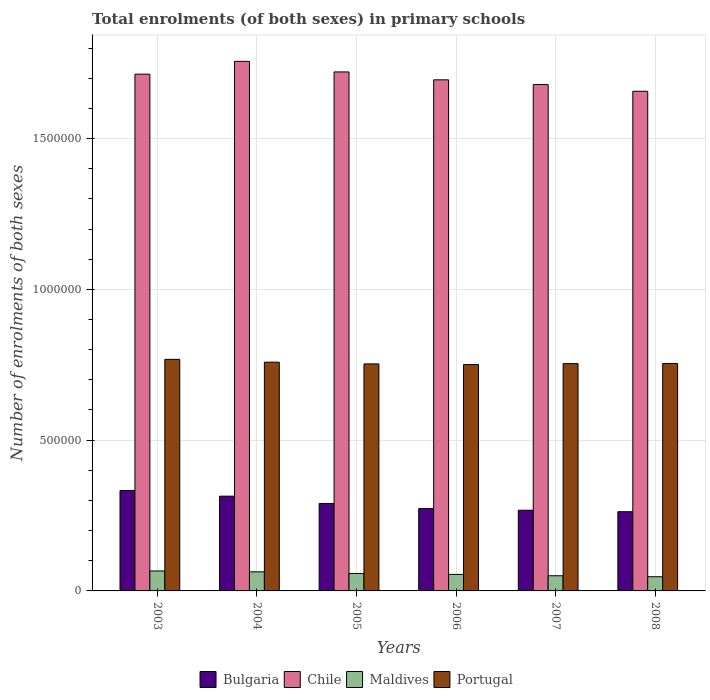Are the number of bars per tick equal to the number of legend labels?
Keep it short and to the point. Yes. Are the number of bars on each tick of the X-axis equal?
Offer a very short reply. Yes. What is the label of the 2nd group of bars from the left?
Your answer should be compact. 2004. In how many cases, is the number of bars for a given year not equal to the number of legend labels?
Give a very brief answer. 0. What is the number of enrolments in primary schools in Bulgaria in 2006?
Give a very brief answer. 2.73e+05. Across all years, what is the maximum number of enrolments in primary schools in Portugal?
Offer a terse response. 7.68e+05. Across all years, what is the minimum number of enrolments in primary schools in Chile?
Give a very brief answer. 1.66e+06. What is the total number of enrolments in primary schools in Maldives in the graph?
Offer a terse response. 3.39e+05. What is the difference between the number of enrolments in primary schools in Bulgaria in 2006 and that in 2007?
Provide a short and direct response. 5461. What is the difference between the number of enrolments in primary schools in Maldives in 2008 and the number of enrolments in primary schools in Portugal in 2004?
Provide a short and direct response. -7.11e+05. What is the average number of enrolments in primary schools in Chile per year?
Give a very brief answer. 1.70e+06. In the year 2005, what is the difference between the number of enrolments in primary schools in Chile and number of enrolments in primary schools in Maldives?
Provide a succinct answer. 1.66e+06. In how many years, is the number of enrolments in primary schools in Chile greater than 400000?
Offer a terse response. 6. What is the ratio of the number of enrolments in primary schools in Bulgaria in 2005 to that in 2008?
Your response must be concise. 1.1. Is the difference between the number of enrolments in primary schools in Chile in 2004 and 2007 greater than the difference between the number of enrolments in primary schools in Maldives in 2004 and 2007?
Your response must be concise. Yes. What is the difference between the highest and the second highest number of enrolments in primary schools in Bulgaria?
Make the answer very short. 1.88e+04. What is the difference between the highest and the lowest number of enrolments in primary schools in Maldives?
Offer a terse response. 1.91e+04. In how many years, is the number of enrolments in primary schools in Portugal greater than the average number of enrolments in primary schools in Portugal taken over all years?
Give a very brief answer. 2. Is the sum of the number of enrolments in primary schools in Chile in 2007 and 2008 greater than the maximum number of enrolments in primary schools in Maldives across all years?
Ensure brevity in your answer.  Yes. Is it the case that in every year, the sum of the number of enrolments in primary schools in Maldives and number of enrolments in primary schools in Portugal is greater than the sum of number of enrolments in primary schools in Chile and number of enrolments in primary schools in Bulgaria?
Keep it short and to the point. Yes. What is the difference between two consecutive major ticks on the Y-axis?
Give a very brief answer. 5.00e+05. Are the values on the major ticks of Y-axis written in scientific E-notation?
Your response must be concise. No. Does the graph contain grids?
Offer a terse response. Yes. Where does the legend appear in the graph?
Ensure brevity in your answer.  Bottom center. What is the title of the graph?
Provide a short and direct response. Total enrolments (of both sexes) in primary schools. What is the label or title of the X-axis?
Make the answer very short. Years. What is the label or title of the Y-axis?
Offer a terse response. Number of enrolments of both sexes. What is the Number of enrolments of both sexes of Bulgaria in 2003?
Your response must be concise. 3.33e+05. What is the Number of enrolments of both sexes in Chile in 2003?
Offer a terse response. 1.71e+06. What is the Number of enrolments of both sexes of Maldives in 2003?
Make the answer very short. 6.62e+04. What is the Number of enrolments of both sexes of Portugal in 2003?
Offer a very short reply. 7.68e+05. What is the Number of enrolments of both sexes in Bulgaria in 2004?
Ensure brevity in your answer.  3.14e+05. What is the Number of enrolments of both sexes of Chile in 2004?
Provide a short and direct response. 1.76e+06. What is the Number of enrolments of both sexes of Maldives in 2004?
Keep it short and to the point. 6.33e+04. What is the Number of enrolments of both sexes of Portugal in 2004?
Provide a short and direct response. 7.58e+05. What is the Number of enrolments of both sexes in Bulgaria in 2005?
Keep it short and to the point. 2.90e+05. What is the Number of enrolments of both sexes in Chile in 2005?
Provide a succinct answer. 1.72e+06. What is the Number of enrolments of both sexes of Maldives in 2005?
Keep it short and to the point. 5.79e+04. What is the Number of enrolments of both sexes of Portugal in 2005?
Your response must be concise. 7.53e+05. What is the Number of enrolments of both sexes of Bulgaria in 2006?
Offer a terse response. 2.73e+05. What is the Number of enrolments of both sexes in Chile in 2006?
Your answer should be compact. 1.69e+06. What is the Number of enrolments of both sexes in Maldives in 2006?
Your answer should be compact. 5.48e+04. What is the Number of enrolments of both sexes of Portugal in 2006?
Keep it short and to the point. 7.50e+05. What is the Number of enrolments of both sexes in Bulgaria in 2007?
Ensure brevity in your answer.  2.68e+05. What is the Number of enrolments of both sexes of Chile in 2007?
Provide a succinct answer. 1.68e+06. What is the Number of enrolments of both sexes of Maldives in 2007?
Your answer should be compact. 5.03e+04. What is the Number of enrolments of both sexes of Portugal in 2007?
Ensure brevity in your answer.  7.54e+05. What is the Number of enrolments of both sexes of Bulgaria in 2008?
Give a very brief answer. 2.63e+05. What is the Number of enrolments of both sexes in Chile in 2008?
Ensure brevity in your answer.  1.66e+06. What is the Number of enrolments of both sexes in Maldives in 2008?
Provide a short and direct response. 4.71e+04. What is the Number of enrolments of both sexes of Portugal in 2008?
Ensure brevity in your answer.  7.54e+05. Across all years, what is the maximum Number of enrolments of both sexes in Bulgaria?
Your answer should be very brief. 3.33e+05. Across all years, what is the maximum Number of enrolments of both sexes of Chile?
Offer a terse response. 1.76e+06. Across all years, what is the maximum Number of enrolments of both sexes of Maldives?
Offer a very short reply. 6.62e+04. Across all years, what is the maximum Number of enrolments of both sexes in Portugal?
Offer a terse response. 7.68e+05. Across all years, what is the minimum Number of enrolments of both sexes in Bulgaria?
Offer a very short reply. 2.63e+05. Across all years, what is the minimum Number of enrolments of both sexes in Chile?
Give a very brief answer. 1.66e+06. Across all years, what is the minimum Number of enrolments of both sexes in Maldives?
Provide a succinct answer. 4.71e+04. Across all years, what is the minimum Number of enrolments of both sexes in Portugal?
Your response must be concise. 7.50e+05. What is the total Number of enrolments of both sexes of Bulgaria in the graph?
Offer a terse response. 1.74e+06. What is the total Number of enrolments of both sexes of Chile in the graph?
Give a very brief answer. 1.02e+07. What is the total Number of enrolments of both sexes in Maldives in the graph?
Your answer should be very brief. 3.39e+05. What is the total Number of enrolments of both sexes in Portugal in the graph?
Keep it short and to the point. 4.54e+06. What is the difference between the Number of enrolments of both sexes of Bulgaria in 2003 and that in 2004?
Provide a succinct answer. 1.88e+04. What is the difference between the Number of enrolments of both sexes of Chile in 2003 and that in 2004?
Offer a very short reply. -4.25e+04. What is the difference between the Number of enrolments of both sexes of Maldives in 2003 and that in 2004?
Provide a short and direct response. 2869. What is the difference between the Number of enrolments of both sexes in Portugal in 2003 and that in 2004?
Your answer should be very brief. 9396. What is the difference between the Number of enrolments of both sexes in Bulgaria in 2003 and that in 2005?
Provide a short and direct response. 4.30e+04. What is the difference between the Number of enrolments of both sexes in Chile in 2003 and that in 2005?
Ensure brevity in your answer.  -7413. What is the difference between the Number of enrolments of both sexes of Maldives in 2003 and that in 2005?
Provide a succinct answer. 8296. What is the difference between the Number of enrolments of both sexes of Portugal in 2003 and that in 2005?
Provide a succinct answer. 1.51e+04. What is the difference between the Number of enrolments of both sexes in Bulgaria in 2003 and that in 2006?
Provide a succinct answer. 6.00e+04. What is the difference between the Number of enrolments of both sexes of Chile in 2003 and that in 2006?
Offer a very short reply. 1.88e+04. What is the difference between the Number of enrolments of both sexes of Maldives in 2003 and that in 2006?
Offer a terse response. 1.14e+04. What is the difference between the Number of enrolments of both sexes of Portugal in 2003 and that in 2006?
Offer a very short reply. 1.74e+04. What is the difference between the Number of enrolments of both sexes of Bulgaria in 2003 and that in 2007?
Offer a very short reply. 6.54e+04. What is the difference between the Number of enrolments of both sexes of Chile in 2003 and that in 2007?
Make the answer very short. 3.45e+04. What is the difference between the Number of enrolments of both sexes in Maldives in 2003 and that in 2007?
Provide a short and direct response. 1.59e+04. What is the difference between the Number of enrolments of both sexes in Portugal in 2003 and that in 2007?
Ensure brevity in your answer.  1.42e+04. What is the difference between the Number of enrolments of both sexes of Bulgaria in 2003 and that in 2008?
Ensure brevity in your answer.  7.03e+04. What is the difference between the Number of enrolments of both sexes in Chile in 2003 and that in 2008?
Give a very brief answer. 5.67e+04. What is the difference between the Number of enrolments of both sexes in Maldives in 2003 and that in 2008?
Your answer should be very brief. 1.91e+04. What is the difference between the Number of enrolments of both sexes of Portugal in 2003 and that in 2008?
Provide a short and direct response. 1.37e+04. What is the difference between the Number of enrolments of both sexes of Bulgaria in 2004 and that in 2005?
Make the answer very short. 2.42e+04. What is the difference between the Number of enrolments of both sexes in Chile in 2004 and that in 2005?
Offer a very short reply. 3.50e+04. What is the difference between the Number of enrolments of both sexes of Maldives in 2004 and that in 2005?
Ensure brevity in your answer.  5427. What is the difference between the Number of enrolments of both sexes of Portugal in 2004 and that in 2005?
Give a very brief answer. 5737. What is the difference between the Number of enrolments of both sexes in Bulgaria in 2004 and that in 2006?
Your answer should be very brief. 4.12e+04. What is the difference between the Number of enrolments of both sexes in Chile in 2004 and that in 2006?
Provide a succinct answer. 6.12e+04. What is the difference between the Number of enrolments of both sexes of Maldives in 2004 and that in 2006?
Make the answer very short. 8530. What is the difference between the Number of enrolments of both sexes of Portugal in 2004 and that in 2006?
Provide a short and direct response. 7983. What is the difference between the Number of enrolments of both sexes of Bulgaria in 2004 and that in 2007?
Offer a terse response. 4.66e+04. What is the difference between the Number of enrolments of both sexes of Chile in 2004 and that in 2007?
Your answer should be compact. 7.70e+04. What is the difference between the Number of enrolments of both sexes of Maldives in 2004 and that in 2007?
Offer a terse response. 1.30e+04. What is the difference between the Number of enrolments of both sexes of Portugal in 2004 and that in 2007?
Give a very brief answer. 4830. What is the difference between the Number of enrolments of both sexes in Bulgaria in 2004 and that in 2008?
Make the answer very short. 5.15e+04. What is the difference between the Number of enrolments of both sexes of Chile in 2004 and that in 2008?
Provide a succinct answer. 9.92e+04. What is the difference between the Number of enrolments of both sexes in Maldives in 2004 and that in 2008?
Your answer should be compact. 1.62e+04. What is the difference between the Number of enrolments of both sexes of Portugal in 2004 and that in 2008?
Your answer should be very brief. 4334. What is the difference between the Number of enrolments of both sexes of Bulgaria in 2005 and that in 2006?
Provide a short and direct response. 1.70e+04. What is the difference between the Number of enrolments of both sexes of Chile in 2005 and that in 2006?
Give a very brief answer. 2.62e+04. What is the difference between the Number of enrolments of both sexes of Maldives in 2005 and that in 2006?
Your response must be concise. 3103. What is the difference between the Number of enrolments of both sexes of Portugal in 2005 and that in 2006?
Provide a short and direct response. 2246. What is the difference between the Number of enrolments of both sexes in Bulgaria in 2005 and that in 2007?
Your answer should be very brief. 2.24e+04. What is the difference between the Number of enrolments of both sexes of Chile in 2005 and that in 2007?
Ensure brevity in your answer.  4.19e+04. What is the difference between the Number of enrolments of both sexes in Maldives in 2005 and that in 2007?
Ensure brevity in your answer.  7603. What is the difference between the Number of enrolments of both sexes in Portugal in 2005 and that in 2007?
Give a very brief answer. -907. What is the difference between the Number of enrolments of both sexes in Bulgaria in 2005 and that in 2008?
Offer a very short reply. 2.73e+04. What is the difference between the Number of enrolments of both sexes of Chile in 2005 and that in 2008?
Offer a very short reply. 6.41e+04. What is the difference between the Number of enrolments of both sexes in Maldives in 2005 and that in 2008?
Your response must be concise. 1.08e+04. What is the difference between the Number of enrolments of both sexes in Portugal in 2005 and that in 2008?
Your response must be concise. -1403. What is the difference between the Number of enrolments of both sexes of Bulgaria in 2006 and that in 2007?
Give a very brief answer. 5461. What is the difference between the Number of enrolments of both sexes in Chile in 2006 and that in 2007?
Your response must be concise. 1.57e+04. What is the difference between the Number of enrolments of both sexes of Maldives in 2006 and that in 2007?
Give a very brief answer. 4500. What is the difference between the Number of enrolments of both sexes of Portugal in 2006 and that in 2007?
Give a very brief answer. -3153. What is the difference between the Number of enrolments of both sexes in Bulgaria in 2006 and that in 2008?
Provide a short and direct response. 1.03e+04. What is the difference between the Number of enrolments of both sexes of Chile in 2006 and that in 2008?
Make the answer very short. 3.80e+04. What is the difference between the Number of enrolments of both sexes of Maldives in 2006 and that in 2008?
Keep it short and to the point. 7688. What is the difference between the Number of enrolments of both sexes of Portugal in 2006 and that in 2008?
Your response must be concise. -3649. What is the difference between the Number of enrolments of both sexes of Bulgaria in 2007 and that in 2008?
Your answer should be very brief. 4883. What is the difference between the Number of enrolments of both sexes in Chile in 2007 and that in 2008?
Offer a very short reply. 2.22e+04. What is the difference between the Number of enrolments of both sexes of Maldives in 2007 and that in 2008?
Keep it short and to the point. 3188. What is the difference between the Number of enrolments of both sexes of Portugal in 2007 and that in 2008?
Ensure brevity in your answer.  -496. What is the difference between the Number of enrolments of both sexes in Bulgaria in 2003 and the Number of enrolments of both sexes in Chile in 2004?
Your answer should be very brief. -1.42e+06. What is the difference between the Number of enrolments of both sexes of Bulgaria in 2003 and the Number of enrolments of both sexes of Maldives in 2004?
Provide a short and direct response. 2.70e+05. What is the difference between the Number of enrolments of both sexes in Bulgaria in 2003 and the Number of enrolments of both sexes in Portugal in 2004?
Make the answer very short. -4.25e+05. What is the difference between the Number of enrolments of both sexes in Chile in 2003 and the Number of enrolments of both sexes in Maldives in 2004?
Your answer should be very brief. 1.65e+06. What is the difference between the Number of enrolments of both sexes of Chile in 2003 and the Number of enrolments of both sexes of Portugal in 2004?
Offer a very short reply. 9.55e+05. What is the difference between the Number of enrolments of both sexes in Maldives in 2003 and the Number of enrolments of both sexes in Portugal in 2004?
Give a very brief answer. -6.92e+05. What is the difference between the Number of enrolments of both sexes of Bulgaria in 2003 and the Number of enrolments of both sexes of Chile in 2005?
Your answer should be compact. -1.39e+06. What is the difference between the Number of enrolments of both sexes of Bulgaria in 2003 and the Number of enrolments of both sexes of Maldives in 2005?
Provide a short and direct response. 2.75e+05. What is the difference between the Number of enrolments of both sexes in Bulgaria in 2003 and the Number of enrolments of both sexes in Portugal in 2005?
Give a very brief answer. -4.20e+05. What is the difference between the Number of enrolments of both sexes of Chile in 2003 and the Number of enrolments of both sexes of Maldives in 2005?
Offer a terse response. 1.66e+06. What is the difference between the Number of enrolments of both sexes in Chile in 2003 and the Number of enrolments of both sexes in Portugal in 2005?
Your answer should be very brief. 9.61e+05. What is the difference between the Number of enrolments of both sexes of Maldives in 2003 and the Number of enrolments of both sexes of Portugal in 2005?
Offer a very short reply. -6.87e+05. What is the difference between the Number of enrolments of both sexes of Bulgaria in 2003 and the Number of enrolments of both sexes of Chile in 2006?
Offer a terse response. -1.36e+06. What is the difference between the Number of enrolments of both sexes of Bulgaria in 2003 and the Number of enrolments of both sexes of Maldives in 2006?
Keep it short and to the point. 2.78e+05. What is the difference between the Number of enrolments of both sexes in Bulgaria in 2003 and the Number of enrolments of both sexes in Portugal in 2006?
Offer a terse response. -4.17e+05. What is the difference between the Number of enrolments of both sexes in Chile in 2003 and the Number of enrolments of both sexes in Maldives in 2006?
Ensure brevity in your answer.  1.66e+06. What is the difference between the Number of enrolments of both sexes in Chile in 2003 and the Number of enrolments of both sexes in Portugal in 2006?
Your answer should be compact. 9.63e+05. What is the difference between the Number of enrolments of both sexes of Maldives in 2003 and the Number of enrolments of both sexes of Portugal in 2006?
Provide a short and direct response. -6.84e+05. What is the difference between the Number of enrolments of both sexes of Bulgaria in 2003 and the Number of enrolments of both sexes of Chile in 2007?
Offer a very short reply. -1.35e+06. What is the difference between the Number of enrolments of both sexes in Bulgaria in 2003 and the Number of enrolments of both sexes in Maldives in 2007?
Your answer should be compact. 2.83e+05. What is the difference between the Number of enrolments of both sexes in Bulgaria in 2003 and the Number of enrolments of both sexes in Portugal in 2007?
Your answer should be compact. -4.21e+05. What is the difference between the Number of enrolments of both sexes in Chile in 2003 and the Number of enrolments of both sexes in Maldives in 2007?
Ensure brevity in your answer.  1.66e+06. What is the difference between the Number of enrolments of both sexes in Chile in 2003 and the Number of enrolments of both sexes in Portugal in 2007?
Your response must be concise. 9.60e+05. What is the difference between the Number of enrolments of both sexes in Maldives in 2003 and the Number of enrolments of both sexes in Portugal in 2007?
Your response must be concise. -6.87e+05. What is the difference between the Number of enrolments of both sexes in Bulgaria in 2003 and the Number of enrolments of both sexes in Chile in 2008?
Give a very brief answer. -1.32e+06. What is the difference between the Number of enrolments of both sexes of Bulgaria in 2003 and the Number of enrolments of both sexes of Maldives in 2008?
Your answer should be very brief. 2.86e+05. What is the difference between the Number of enrolments of both sexes in Bulgaria in 2003 and the Number of enrolments of both sexes in Portugal in 2008?
Your answer should be very brief. -4.21e+05. What is the difference between the Number of enrolments of both sexes in Chile in 2003 and the Number of enrolments of both sexes in Maldives in 2008?
Keep it short and to the point. 1.67e+06. What is the difference between the Number of enrolments of both sexes of Chile in 2003 and the Number of enrolments of both sexes of Portugal in 2008?
Offer a terse response. 9.59e+05. What is the difference between the Number of enrolments of both sexes in Maldives in 2003 and the Number of enrolments of both sexes in Portugal in 2008?
Your answer should be compact. -6.88e+05. What is the difference between the Number of enrolments of both sexes of Bulgaria in 2004 and the Number of enrolments of both sexes of Chile in 2005?
Give a very brief answer. -1.41e+06. What is the difference between the Number of enrolments of both sexes in Bulgaria in 2004 and the Number of enrolments of both sexes in Maldives in 2005?
Your response must be concise. 2.56e+05. What is the difference between the Number of enrolments of both sexes of Bulgaria in 2004 and the Number of enrolments of both sexes of Portugal in 2005?
Give a very brief answer. -4.39e+05. What is the difference between the Number of enrolments of both sexes in Chile in 2004 and the Number of enrolments of both sexes in Maldives in 2005?
Your answer should be compact. 1.70e+06. What is the difference between the Number of enrolments of both sexes of Chile in 2004 and the Number of enrolments of both sexes of Portugal in 2005?
Your answer should be very brief. 1.00e+06. What is the difference between the Number of enrolments of both sexes in Maldives in 2004 and the Number of enrolments of both sexes in Portugal in 2005?
Your response must be concise. -6.89e+05. What is the difference between the Number of enrolments of both sexes of Bulgaria in 2004 and the Number of enrolments of both sexes of Chile in 2006?
Ensure brevity in your answer.  -1.38e+06. What is the difference between the Number of enrolments of both sexes of Bulgaria in 2004 and the Number of enrolments of both sexes of Maldives in 2006?
Offer a very short reply. 2.59e+05. What is the difference between the Number of enrolments of both sexes of Bulgaria in 2004 and the Number of enrolments of both sexes of Portugal in 2006?
Ensure brevity in your answer.  -4.36e+05. What is the difference between the Number of enrolments of both sexes in Chile in 2004 and the Number of enrolments of both sexes in Maldives in 2006?
Provide a short and direct response. 1.70e+06. What is the difference between the Number of enrolments of both sexes of Chile in 2004 and the Number of enrolments of both sexes of Portugal in 2006?
Offer a very short reply. 1.01e+06. What is the difference between the Number of enrolments of both sexes of Maldives in 2004 and the Number of enrolments of both sexes of Portugal in 2006?
Provide a succinct answer. -6.87e+05. What is the difference between the Number of enrolments of both sexes in Bulgaria in 2004 and the Number of enrolments of both sexes in Chile in 2007?
Make the answer very short. -1.36e+06. What is the difference between the Number of enrolments of both sexes in Bulgaria in 2004 and the Number of enrolments of both sexes in Maldives in 2007?
Offer a very short reply. 2.64e+05. What is the difference between the Number of enrolments of both sexes of Bulgaria in 2004 and the Number of enrolments of both sexes of Portugal in 2007?
Your answer should be compact. -4.39e+05. What is the difference between the Number of enrolments of both sexes of Chile in 2004 and the Number of enrolments of both sexes of Maldives in 2007?
Provide a short and direct response. 1.71e+06. What is the difference between the Number of enrolments of both sexes of Chile in 2004 and the Number of enrolments of both sexes of Portugal in 2007?
Offer a very short reply. 1.00e+06. What is the difference between the Number of enrolments of both sexes of Maldives in 2004 and the Number of enrolments of both sexes of Portugal in 2007?
Offer a terse response. -6.90e+05. What is the difference between the Number of enrolments of both sexes of Bulgaria in 2004 and the Number of enrolments of both sexes of Chile in 2008?
Provide a succinct answer. -1.34e+06. What is the difference between the Number of enrolments of both sexes in Bulgaria in 2004 and the Number of enrolments of both sexes in Maldives in 2008?
Your response must be concise. 2.67e+05. What is the difference between the Number of enrolments of both sexes of Bulgaria in 2004 and the Number of enrolments of both sexes of Portugal in 2008?
Offer a terse response. -4.40e+05. What is the difference between the Number of enrolments of both sexes in Chile in 2004 and the Number of enrolments of both sexes in Maldives in 2008?
Offer a terse response. 1.71e+06. What is the difference between the Number of enrolments of both sexes of Chile in 2004 and the Number of enrolments of both sexes of Portugal in 2008?
Make the answer very short. 1.00e+06. What is the difference between the Number of enrolments of both sexes of Maldives in 2004 and the Number of enrolments of both sexes of Portugal in 2008?
Your response must be concise. -6.91e+05. What is the difference between the Number of enrolments of both sexes in Bulgaria in 2005 and the Number of enrolments of both sexes in Chile in 2006?
Your answer should be very brief. -1.40e+06. What is the difference between the Number of enrolments of both sexes in Bulgaria in 2005 and the Number of enrolments of both sexes in Maldives in 2006?
Your answer should be compact. 2.35e+05. What is the difference between the Number of enrolments of both sexes of Bulgaria in 2005 and the Number of enrolments of both sexes of Portugal in 2006?
Provide a short and direct response. -4.60e+05. What is the difference between the Number of enrolments of both sexes of Chile in 2005 and the Number of enrolments of both sexes of Maldives in 2006?
Provide a succinct answer. 1.67e+06. What is the difference between the Number of enrolments of both sexes in Chile in 2005 and the Number of enrolments of both sexes in Portugal in 2006?
Your response must be concise. 9.70e+05. What is the difference between the Number of enrolments of both sexes in Maldives in 2005 and the Number of enrolments of both sexes in Portugal in 2006?
Your answer should be compact. -6.93e+05. What is the difference between the Number of enrolments of both sexes of Bulgaria in 2005 and the Number of enrolments of both sexes of Chile in 2007?
Provide a short and direct response. -1.39e+06. What is the difference between the Number of enrolments of both sexes in Bulgaria in 2005 and the Number of enrolments of both sexes in Maldives in 2007?
Provide a short and direct response. 2.40e+05. What is the difference between the Number of enrolments of both sexes in Bulgaria in 2005 and the Number of enrolments of both sexes in Portugal in 2007?
Make the answer very short. -4.64e+05. What is the difference between the Number of enrolments of both sexes in Chile in 2005 and the Number of enrolments of both sexes in Maldives in 2007?
Make the answer very short. 1.67e+06. What is the difference between the Number of enrolments of both sexes in Chile in 2005 and the Number of enrolments of both sexes in Portugal in 2007?
Provide a short and direct response. 9.67e+05. What is the difference between the Number of enrolments of both sexes in Maldives in 2005 and the Number of enrolments of both sexes in Portugal in 2007?
Offer a terse response. -6.96e+05. What is the difference between the Number of enrolments of both sexes in Bulgaria in 2005 and the Number of enrolments of both sexes in Chile in 2008?
Give a very brief answer. -1.37e+06. What is the difference between the Number of enrolments of both sexes of Bulgaria in 2005 and the Number of enrolments of both sexes of Maldives in 2008?
Make the answer very short. 2.43e+05. What is the difference between the Number of enrolments of both sexes in Bulgaria in 2005 and the Number of enrolments of both sexes in Portugal in 2008?
Provide a succinct answer. -4.64e+05. What is the difference between the Number of enrolments of both sexes of Chile in 2005 and the Number of enrolments of both sexes of Maldives in 2008?
Provide a succinct answer. 1.67e+06. What is the difference between the Number of enrolments of both sexes of Chile in 2005 and the Number of enrolments of both sexes of Portugal in 2008?
Give a very brief answer. 9.67e+05. What is the difference between the Number of enrolments of both sexes of Maldives in 2005 and the Number of enrolments of both sexes of Portugal in 2008?
Your response must be concise. -6.96e+05. What is the difference between the Number of enrolments of both sexes in Bulgaria in 2006 and the Number of enrolments of both sexes in Chile in 2007?
Provide a short and direct response. -1.41e+06. What is the difference between the Number of enrolments of both sexes in Bulgaria in 2006 and the Number of enrolments of both sexes in Maldives in 2007?
Provide a short and direct response. 2.23e+05. What is the difference between the Number of enrolments of both sexes of Bulgaria in 2006 and the Number of enrolments of both sexes of Portugal in 2007?
Provide a succinct answer. -4.81e+05. What is the difference between the Number of enrolments of both sexes in Chile in 2006 and the Number of enrolments of both sexes in Maldives in 2007?
Provide a short and direct response. 1.64e+06. What is the difference between the Number of enrolments of both sexes in Chile in 2006 and the Number of enrolments of both sexes in Portugal in 2007?
Provide a succinct answer. 9.41e+05. What is the difference between the Number of enrolments of both sexes in Maldives in 2006 and the Number of enrolments of both sexes in Portugal in 2007?
Ensure brevity in your answer.  -6.99e+05. What is the difference between the Number of enrolments of both sexes in Bulgaria in 2006 and the Number of enrolments of both sexes in Chile in 2008?
Ensure brevity in your answer.  -1.38e+06. What is the difference between the Number of enrolments of both sexes of Bulgaria in 2006 and the Number of enrolments of both sexes of Maldives in 2008?
Keep it short and to the point. 2.26e+05. What is the difference between the Number of enrolments of both sexes of Bulgaria in 2006 and the Number of enrolments of both sexes of Portugal in 2008?
Make the answer very short. -4.81e+05. What is the difference between the Number of enrolments of both sexes of Chile in 2006 and the Number of enrolments of both sexes of Maldives in 2008?
Offer a very short reply. 1.65e+06. What is the difference between the Number of enrolments of both sexes of Chile in 2006 and the Number of enrolments of both sexes of Portugal in 2008?
Give a very brief answer. 9.41e+05. What is the difference between the Number of enrolments of both sexes of Maldives in 2006 and the Number of enrolments of both sexes of Portugal in 2008?
Provide a succinct answer. -6.99e+05. What is the difference between the Number of enrolments of both sexes in Bulgaria in 2007 and the Number of enrolments of both sexes in Chile in 2008?
Ensure brevity in your answer.  -1.39e+06. What is the difference between the Number of enrolments of both sexes in Bulgaria in 2007 and the Number of enrolments of both sexes in Maldives in 2008?
Offer a terse response. 2.21e+05. What is the difference between the Number of enrolments of both sexes of Bulgaria in 2007 and the Number of enrolments of both sexes of Portugal in 2008?
Offer a terse response. -4.87e+05. What is the difference between the Number of enrolments of both sexes in Chile in 2007 and the Number of enrolments of both sexes in Maldives in 2008?
Your response must be concise. 1.63e+06. What is the difference between the Number of enrolments of both sexes in Chile in 2007 and the Number of enrolments of both sexes in Portugal in 2008?
Your answer should be very brief. 9.25e+05. What is the difference between the Number of enrolments of both sexes of Maldives in 2007 and the Number of enrolments of both sexes of Portugal in 2008?
Your answer should be very brief. -7.04e+05. What is the average Number of enrolments of both sexes in Bulgaria per year?
Your response must be concise. 2.90e+05. What is the average Number of enrolments of both sexes in Chile per year?
Your response must be concise. 1.70e+06. What is the average Number of enrolments of both sexes of Maldives per year?
Keep it short and to the point. 5.66e+04. What is the average Number of enrolments of both sexes of Portugal per year?
Ensure brevity in your answer.  7.56e+05. In the year 2003, what is the difference between the Number of enrolments of both sexes of Bulgaria and Number of enrolments of both sexes of Chile?
Make the answer very short. -1.38e+06. In the year 2003, what is the difference between the Number of enrolments of both sexes of Bulgaria and Number of enrolments of both sexes of Maldives?
Keep it short and to the point. 2.67e+05. In the year 2003, what is the difference between the Number of enrolments of both sexes of Bulgaria and Number of enrolments of both sexes of Portugal?
Provide a short and direct response. -4.35e+05. In the year 2003, what is the difference between the Number of enrolments of both sexes of Chile and Number of enrolments of both sexes of Maldives?
Your answer should be very brief. 1.65e+06. In the year 2003, what is the difference between the Number of enrolments of both sexes of Chile and Number of enrolments of both sexes of Portugal?
Ensure brevity in your answer.  9.46e+05. In the year 2003, what is the difference between the Number of enrolments of both sexes in Maldives and Number of enrolments of both sexes in Portugal?
Offer a terse response. -7.02e+05. In the year 2004, what is the difference between the Number of enrolments of both sexes in Bulgaria and Number of enrolments of both sexes in Chile?
Give a very brief answer. -1.44e+06. In the year 2004, what is the difference between the Number of enrolments of both sexes of Bulgaria and Number of enrolments of both sexes of Maldives?
Ensure brevity in your answer.  2.51e+05. In the year 2004, what is the difference between the Number of enrolments of both sexes of Bulgaria and Number of enrolments of both sexes of Portugal?
Your answer should be very brief. -4.44e+05. In the year 2004, what is the difference between the Number of enrolments of both sexes in Chile and Number of enrolments of both sexes in Maldives?
Make the answer very short. 1.69e+06. In the year 2004, what is the difference between the Number of enrolments of both sexes of Chile and Number of enrolments of both sexes of Portugal?
Your answer should be compact. 9.98e+05. In the year 2004, what is the difference between the Number of enrolments of both sexes in Maldives and Number of enrolments of both sexes in Portugal?
Provide a succinct answer. -6.95e+05. In the year 2005, what is the difference between the Number of enrolments of both sexes of Bulgaria and Number of enrolments of both sexes of Chile?
Your response must be concise. -1.43e+06. In the year 2005, what is the difference between the Number of enrolments of both sexes of Bulgaria and Number of enrolments of both sexes of Maldives?
Offer a terse response. 2.32e+05. In the year 2005, what is the difference between the Number of enrolments of both sexes in Bulgaria and Number of enrolments of both sexes in Portugal?
Provide a short and direct response. -4.63e+05. In the year 2005, what is the difference between the Number of enrolments of both sexes in Chile and Number of enrolments of both sexes in Maldives?
Keep it short and to the point. 1.66e+06. In the year 2005, what is the difference between the Number of enrolments of both sexes of Chile and Number of enrolments of both sexes of Portugal?
Offer a terse response. 9.68e+05. In the year 2005, what is the difference between the Number of enrolments of both sexes in Maldives and Number of enrolments of both sexes in Portugal?
Ensure brevity in your answer.  -6.95e+05. In the year 2006, what is the difference between the Number of enrolments of both sexes in Bulgaria and Number of enrolments of both sexes in Chile?
Offer a terse response. -1.42e+06. In the year 2006, what is the difference between the Number of enrolments of both sexes of Bulgaria and Number of enrolments of both sexes of Maldives?
Provide a short and direct response. 2.18e+05. In the year 2006, what is the difference between the Number of enrolments of both sexes of Bulgaria and Number of enrolments of both sexes of Portugal?
Your answer should be compact. -4.77e+05. In the year 2006, what is the difference between the Number of enrolments of both sexes of Chile and Number of enrolments of both sexes of Maldives?
Your response must be concise. 1.64e+06. In the year 2006, what is the difference between the Number of enrolments of both sexes of Chile and Number of enrolments of both sexes of Portugal?
Make the answer very short. 9.44e+05. In the year 2006, what is the difference between the Number of enrolments of both sexes of Maldives and Number of enrolments of both sexes of Portugal?
Provide a succinct answer. -6.96e+05. In the year 2007, what is the difference between the Number of enrolments of both sexes in Bulgaria and Number of enrolments of both sexes in Chile?
Make the answer very short. -1.41e+06. In the year 2007, what is the difference between the Number of enrolments of both sexes of Bulgaria and Number of enrolments of both sexes of Maldives?
Offer a very short reply. 2.17e+05. In the year 2007, what is the difference between the Number of enrolments of both sexes of Bulgaria and Number of enrolments of both sexes of Portugal?
Provide a succinct answer. -4.86e+05. In the year 2007, what is the difference between the Number of enrolments of both sexes of Chile and Number of enrolments of both sexes of Maldives?
Make the answer very short. 1.63e+06. In the year 2007, what is the difference between the Number of enrolments of both sexes of Chile and Number of enrolments of both sexes of Portugal?
Offer a very short reply. 9.25e+05. In the year 2007, what is the difference between the Number of enrolments of both sexes of Maldives and Number of enrolments of both sexes of Portugal?
Your response must be concise. -7.03e+05. In the year 2008, what is the difference between the Number of enrolments of both sexes of Bulgaria and Number of enrolments of both sexes of Chile?
Make the answer very short. -1.39e+06. In the year 2008, what is the difference between the Number of enrolments of both sexes of Bulgaria and Number of enrolments of both sexes of Maldives?
Provide a succinct answer. 2.16e+05. In the year 2008, what is the difference between the Number of enrolments of both sexes of Bulgaria and Number of enrolments of both sexes of Portugal?
Ensure brevity in your answer.  -4.91e+05. In the year 2008, what is the difference between the Number of enrolments of both sexes of Chile and Number of enrolments of both sexes of Maldives?
Keep it short and to the point. 1.61e+06. In the year 2008, what is the difference between the Number of enrolments of both sexes in Chile and Number of enrolments of both sexes in Portugal?
Provide a succinct answer. 9.03e+05. In the year 2008, what is the difference between the Number of enrolments of both sexes of Maldives and Number of enrolments of both sexes of Portugal?
Your answer should be very brief. -7.07e+05. What is the ratio of the Number of enrolments of both sexes of Bulgaria in 2003 to that in 2004?
Your response must be concise. 1.06. What is the ratio of the Number of enrolments of both sexes in Chile in 2003 to that in 2004?
Offer a terse response. 0.98. What is the ratio of the Number of enrolments of both sexes in Maldives in 2003 to that in 2004?
Your answer should be compact. 1.05. What is the ratio of the Number of enrolments of both sexes in Portugal in 2003 to that in 2004?
Provide a succinct answer. 1.01. What is the ratio of the Number of enrolments of both sexes of Bulgaria in 2003 to that in 2005?
Offer a terse response. 1.15. What is the ratio of the Number of enrolments of both sexes in Maldives in 2003 to that in 2005?
Make the answer very short. 1.14. What is the ratio of the Number of enrolments of both sexes of Portugal in 2003 to that in 2005?
Your answer should be very brief. 1.02. What is the ratio of the Number of enrolments of both sexes in Bulgaria in 2003 to that in 2006?
Give a very brief answer. 1.22. What is the ratio of the Number of enrolments of both sexes of Chile in 2003 to that in 2006?
Give a very brief answer. 1.01. What is the ratio of the Number of enrolments of both sexes in Maldives in 2003 to that in 2006?
Provide a short and direct response. 1.21. What is the ratio of the Number of enrolments of both sexes of Portugal in 2003 to that in 2006?
Make the answer very short. 1.02. What is the ratio of the Number of enrolments of both sexes in Bulgaria in 2003 to that in 2007?
Ensure brevity in your answer.  1.24. What is the ratio of the Number of enrolments of both sexes of Chile in 2003 to that in 2007?
Give a very brief answer. 1.02. What is the ratio of the Number of enrolments of both sexes of Maldives in 2003 to that in 2007?
Provide a succinct answer. 1.32. What is the ratio of the Number of enrolments of both sexes in Portugal in 2003 to that in 2007?
Ensure brevity in your answer.  1.02. What is the ratio of the Number of enrolments of both sexes of Bulgaria in 2003 to that in 2008?
Offer a very short reply. 1.27. What is the ratio of the Number of enrolments of both sexes of Chile in 2003 to that in 2008?
Offer a very short reply. 1.03. What is the ratio of the Number of enrolments of both sexes in Maldives in 2003 to that in 2008?
Provide a succinct answer. 1.41. What is the ratio of the Number of enrolments of both sexes of Portugal in 2003 to that in 2008?
Your answer should be compact. 1.02. What is the ratio of the Number of enrolments of both sexes in Bulgaria in 2004 to that in 2005?
Give a very brief answer. 1.08. What is the ratio of the Number of enrolments of both sexes in Chile in 2004 to that in 2005?
Keep it short and to the point. 1.02. What is the ratio of the Number of enrolments of both sexes of Maldives in 2004 to that in 2005?
Your answer should be very brief. 1.09. What is the ratio of the Number of enrolments of both sexes in Portugal in 2004 to that in 2005?
Keep it short and to the point. 1.01. What is the ratio of the Number of enrolments of both sexes of Bulgaria in 2004 to that in 2006?
Your answer should be compact. 1.15. What is the ratio of the Number of enrolments of both sexes in Chile in 2004 to that in 2006?
Keep it short and to the point. 1.04. What is the ratio of the Number of enrolments of both sexes in Maldives in 2004 to that in 2006?
Offer a terse response. 1.16. What is the ratio of the Number of enrolments of both sexes in Portugal in 2004 to that in 2006?
Offer a terse response. 1.01. What is the ratio of the Number of enrolments of both sexes in Bulgaria in 2004 to that in 2007?
Your answer should be very brief. 1.17. What is the ratio of the Number of enrolments of both sexes in Chile in 2004 to that in 2007?
Offer a terse response. 1.05. What is the ratio of the Number of enrolments of both sexes in Maldives in 2004 to that in 2007?
Offer a terse response. 1.26. What is the ratio of the Number of enrolments of both sexes in Portugal in 2004 to that in 2007?
Ensure brevity in your answer.  1.01. What is the ratio of the Number of enrolments of both sexes of Bulgaria in 2004 to that in 2008?
Provide a succinct answer. 1.2. What is the ratio of the Number of enrolments of both sexes in Chile in 2004 to that in 2008?
Provide a succinct answer. 1.06. What is the ratio of the Number of enrolments of both sexes of Maldives in 2004 to that in 2008?
Keep it short and to the point. 1.34. What is the ratio of the Number of enrolments of both sexes in Portugal in 2004 to that in 2008?
Provide a succinct answer. 1.01. What is the ratio of the Number of enrolments of both sexes in Bulgaria in 2005 to that in 2006?
Ensure brevity in your answer.  1.06. What is the ratio of the Number of enrolments of both sexes in Chile in 2005 to that in 2006?
Provide a succinct answer. 1.02. What is the ratio of the Number of enrolments of both sexes of Maldives in 2005 to that in 2006?
Your answer should be compact. 1.06. What is the ratio of the Number of enrolments of both sexes of Portugal in 2005 to that in 2006?
Make the answer very short. 1. What is the ratio of the Number of enrolments of both sexes in Bulgaria in 2005 to that in 2007?
Offer a very short reply. 1.08. What is the ratio of the Number of enrolments of both sexes of Maldives in 2005 to that in 2007?
Give a very brief answer. 1.15. What is the ratio of the Number of enrolments of both sexes in Portugal in 2005 to that in 2007?
Give a very brief answer. 1. What is the ratio of the Number of enrolments of both sexes in Bulgaria in 2005 to that in 2008?
Your answer should be very brief. 1.1. What is the ratio of the Number of enrolments of both sexes of Chile in 2005 to that in 2008?
Ensure brevity in your answer.  1.04. What is the ratio of the Number of enrolments of both sexes of Maldives in 2005 to that in 2008?
Make the answer very short. 1.23. What is the ratio of the Number of enrolments of both sexes of Bulgaria in 2006 to that in 2007?
Provide a short and direct response. 1.02. What is the ratio of the Number of enrolments of both sexes in Chile in 2006 to that in 2007?
Offer a very short reply. 1.01. What is the ratio of the Number of enrolments of both sexes of Maldives in 2006 to that in 2007?
Provide a short and direct response. 1.09. What is the ratio of the Number of enrolments of both sexes in Bulgaria in 2006 to that in 2008?
Your answer should be compact. 1.04. What is the ratio of the Number of enrolments of both sexes of Chile in 2006 to that in 2008?
Offer a terse response. 1.02. What is the ratio of the Number of enrolments of both sexes of Maldives in 2006 to that in 2008?
Ensure brevity in your answer.  1.16. What is the ratio of the Number of enrolments of both sexes of Portugal in 2006 to that in 2008?
Offer a terse response. 1. What is the ratio of the Number of enrolments of both sexes of Bulgaria in 2007 to that in 2008?
Offer a terse response. 1.02. What is the ratio of the Number of enrolments of both sexes in Chile in 2007 to that in 2008?
Ensure brevity in your answer.  1.01. What is the ratio of the Number of enrolments of both sexes in Maldives in 2007 to that in 2008?
Make the answer very short. 1.07. What is the difference between the highest and the second highest Number of enrolments of both sexes of Bulgaria?
Your answer should be very brief. 1.88e+04. What is the difference between the highest and the second highest Number of enrolments of both sexes in Chile?
Your answer should be compact. 3.50e+04. What is the difference between the highest and the second highest Number of enrolments of both sexes of Maldives?
Provide a short and direct response. 2869. What is the difference between the highest and the second highest Number of enrolments of both sexes of Portugal?
Your response must be concise. 9396. What is the difference between the highest and the lowest Number of enrolments of both sexes in Bulgaria?
Your answer should be very brief. 7.03e+04. What is the difference between the highest and the lowest Number of enrolments of both sexes in Chile?
Offer a very short reply. 9.92e+04. What is the difference between the highest and the lowest Number of enrolments of both sexes of Maldives?
Give a very brief answer. 1.91e+04. What is the difference between the highest and the lowest Number of enrolments of both sexes in Portugal?
Provide a short and direct response. 1.74e+04. 